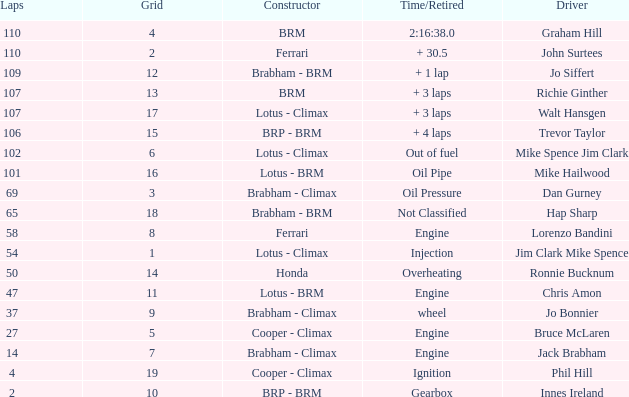What driver has a Time/Retired of 2:16:38.0? Graham Hill. 